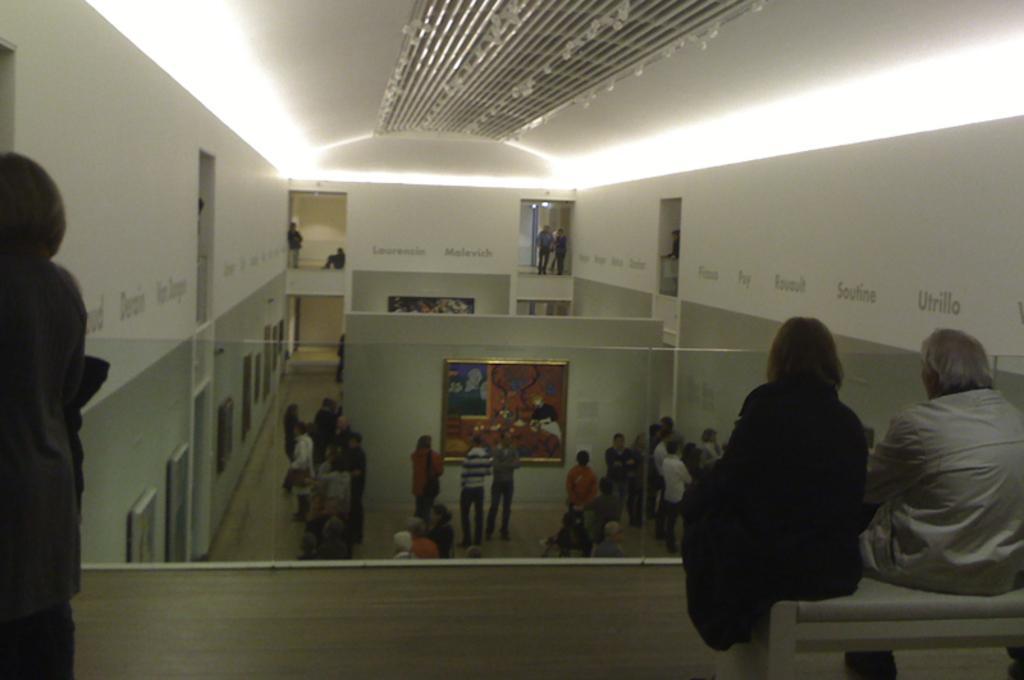Could you give a brief overview of what you see in this image? In this image, we can see the inside view of the hall. Here we can see some photo frames, a group of people. Few are standing. Here we can see two people sitting on a bench. Top of the image, there is a roof. 